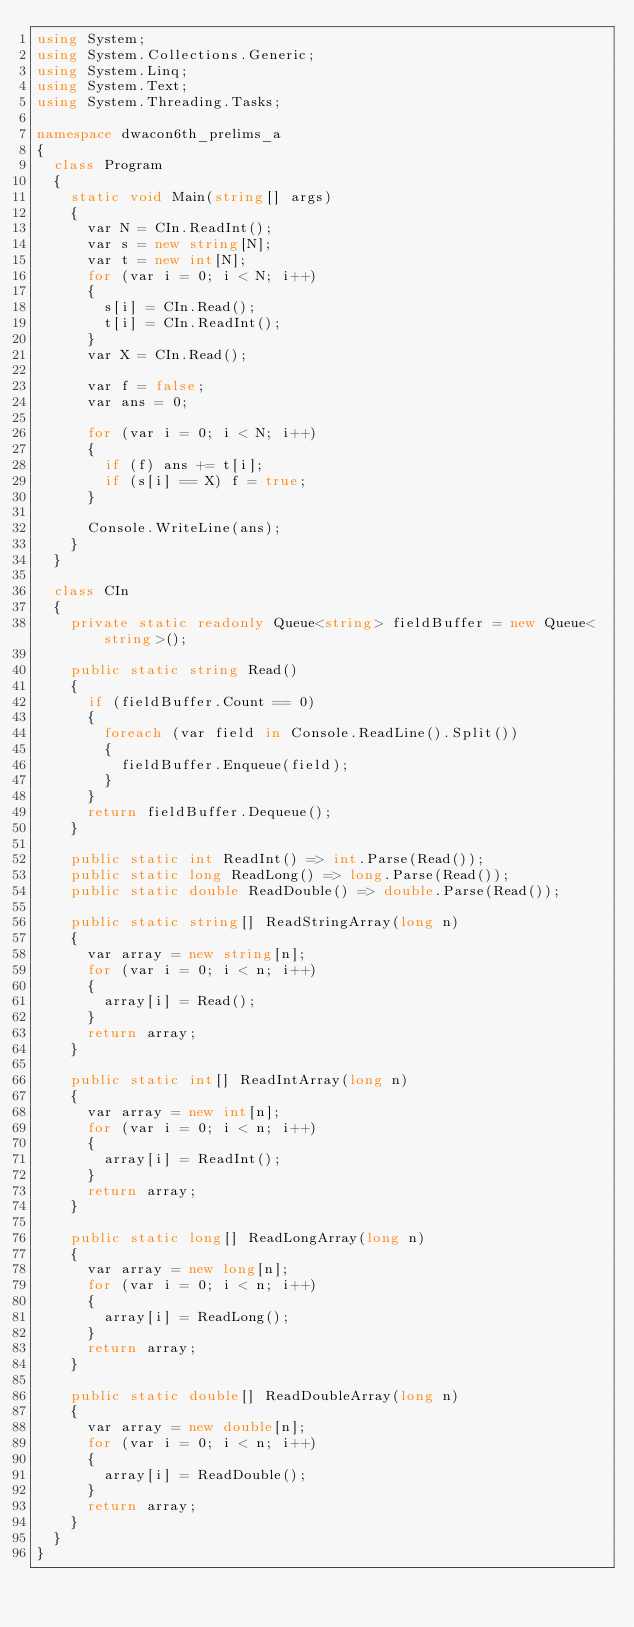<code> <loc_0><loc_0><loc_500><loc_500><_C#_>using System;
using System.Collections.Generic;
using System.Linq;
using System.Text;
using System.Threading.Tasks;

namespace dwacon6th_prelims_a
{
  class Program
  {
    static void Main(string[] args)
    {
      var N = CIn.ReadInt();
      var s = new string[N];
      var t = new int[N];
      for (var i = 0; i < N; i++)
      {
        s[i] = CIn.Read();
        t[i] = CIn.ReadInt();
      }
      var X = CIn.Read();

      var f = false;
      var ans = 0;

      for (var i = 0; i < N; i++)
      {
        if (f) ans += t[i];
        if (s[i] == X) f = true;
      }

      Console.WriteLine(ans);
    }
  }

  class CIn
  {
    private static readonly Queue<string> fieldBuffer = new Queue<string>();

    public static string Read()
    {
      if (fieldBuffer.Count == 0)
      {
        foreach (var field in Console.ReadLine().Split())
        {
          fieldBuffer.Enqueue(field);
        }
      }
      return fieldBuffer.Dequeue();
    }

    public static int ReadInt() => int.Parse(Read());
    public static long ReadLong() => long.Parse(Read());
    public static double ReadDouble() => double.Parse(Read());

    public static string[] ReadStringArray(long n)
    {
      var array = new string[n];
      for (var i = 0; i < n; i++)
      {
        array[i] = Read();
      }
      return array;
    }

    public static int[] ReadIntArray(long n)
    {
      var array = new int[n];
      for (var i = 0; i < n; i++)
      {
        array[i] = ReadInt();
      }
      return array;
    }

    public static long[] ReadLongArray(long n)
    {
      var array = new long[n];
      for (var i = 0; i < n; i++)
      {
        array[i] = ReadLong();
      }
      return array;
    }

    public static double[] ReadDoubleArray(long n)
    {
      var array = new double[n];
      for (var i = 0; i < n; i++)
      {
        array[i] = ReadDouble();
      }
      return array;
    }
  }
}
</code> 